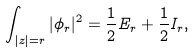<formula> <loc_0><loc_0><loc_500><loc_500>\int _ { | z | = r } | \phi _ { r } | ^ { 2 } = \frac { 1 } { 2 } E _ { r } + \frac { 1 } { 2 } I _ { r } ,</formula> 